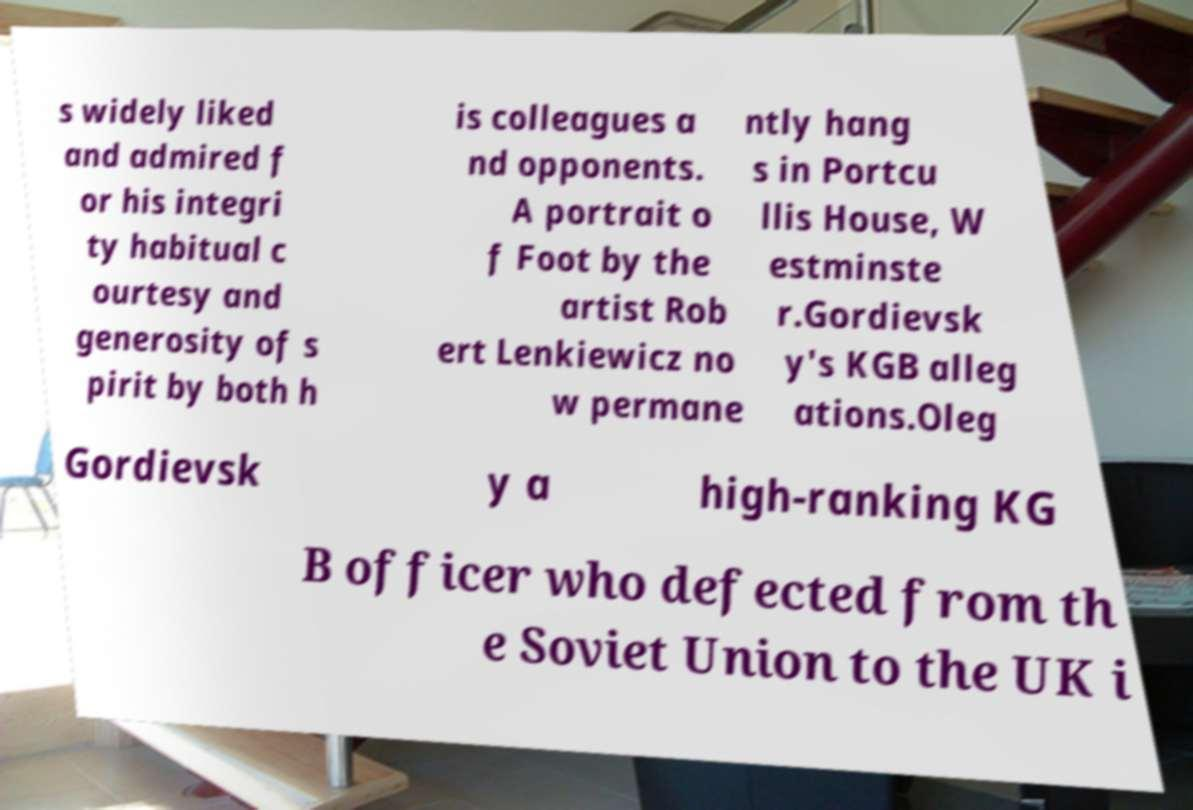Could you extract and type out the text from this image? s widely liked and admired f or his integri ty habitual c ourtesy and generosity of s pirit by both h is colleagues a nd opponents. A portrait o f Foot by the artist Rob ert Lenkiewicz no w permane ntly hang s in Portcu llis House, W estminste r.Gordievsk y's KGB alleg ations.Oleg Gordievsk y a high-ranking KG B officer who defected from th e Soviet Union to the UK i 